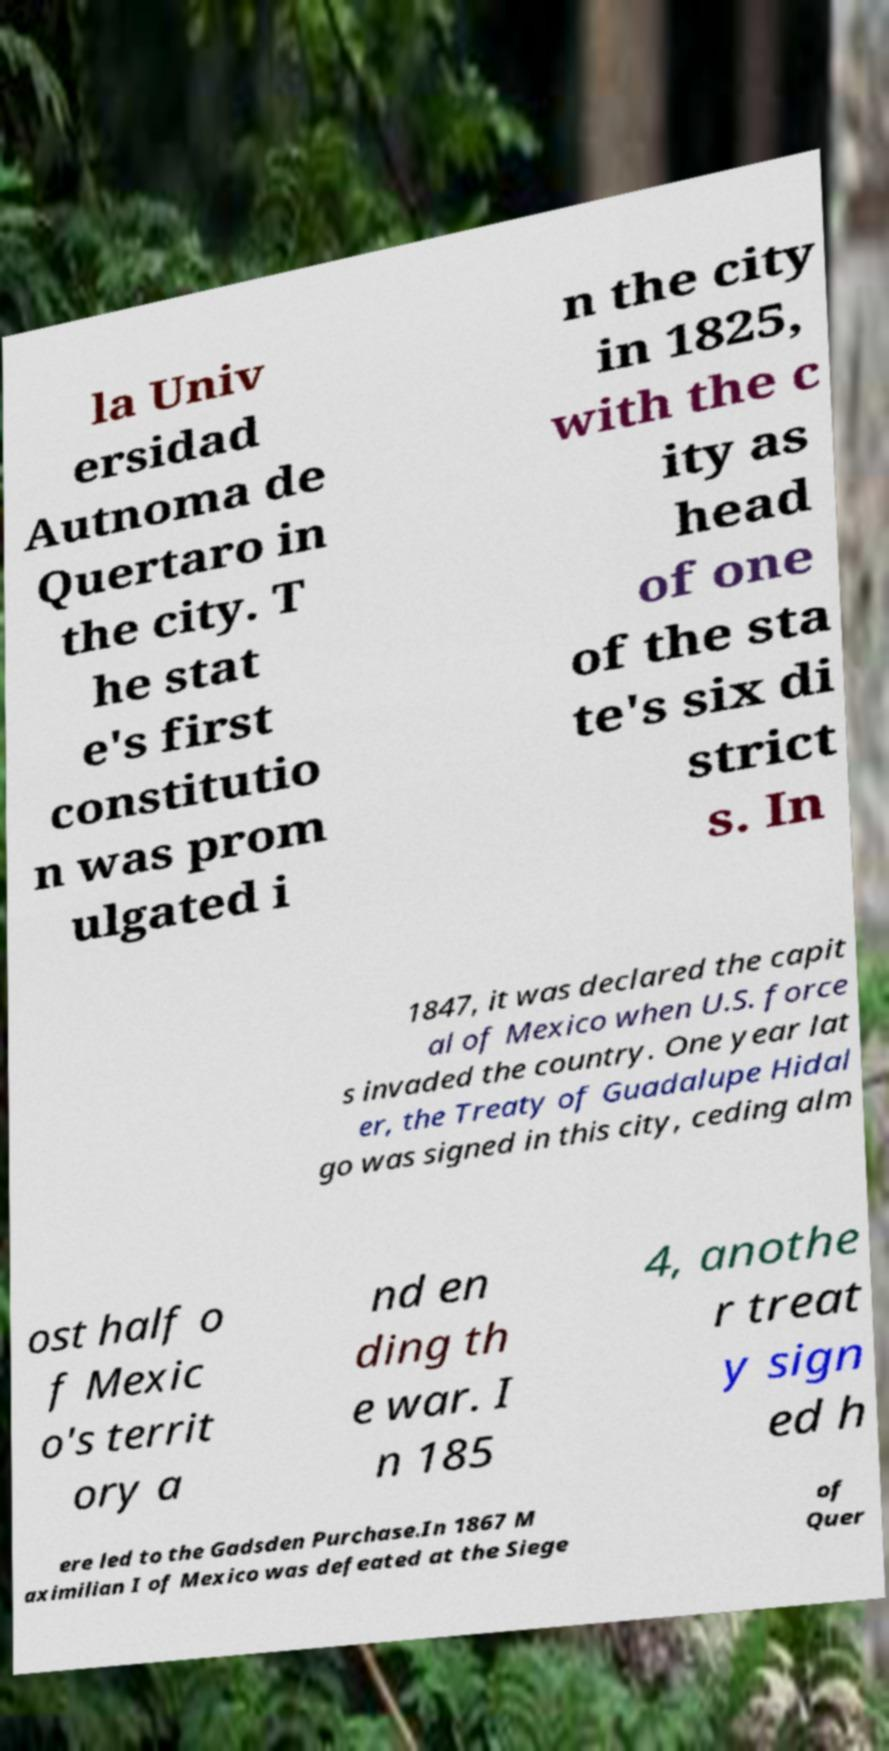What messages or text are displayed in this image? I need them in a readable, typed format. la Univ ersidad Autnoma de Quertaro in the city. T he stat e's first constitutio n was prom ulgated i n the city in 1825, with the c ity as head of one of the sta te's six di strict s. In 1847, it was declared the capit al of Mexico when U.S. force s invaded the country. One year lat er, the Treaty of Guadalupe Hidal go was signed in this city, ceding alm ost half o f Mexic o's territ ory a nd en ding th e war. I n 185 4, anothe r treat y sign ed h ere led to the Gadsden Purchase.In 1867 M aximilian I of Mexico was defeated at the Siege of Quer 